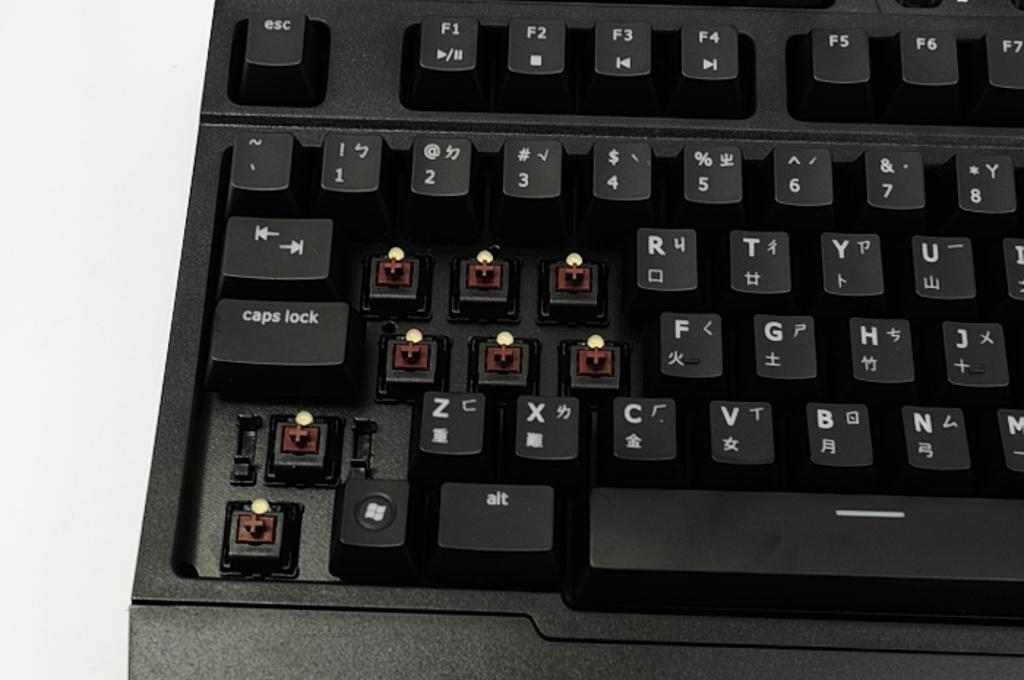<image>
Present a compact description of the photo's key features. A black keyboard with letter keys missing under the numbers 1,2 and 3. 